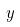<formula> <loc_0><loc_0><loc_500><loc_500>y</formula> 